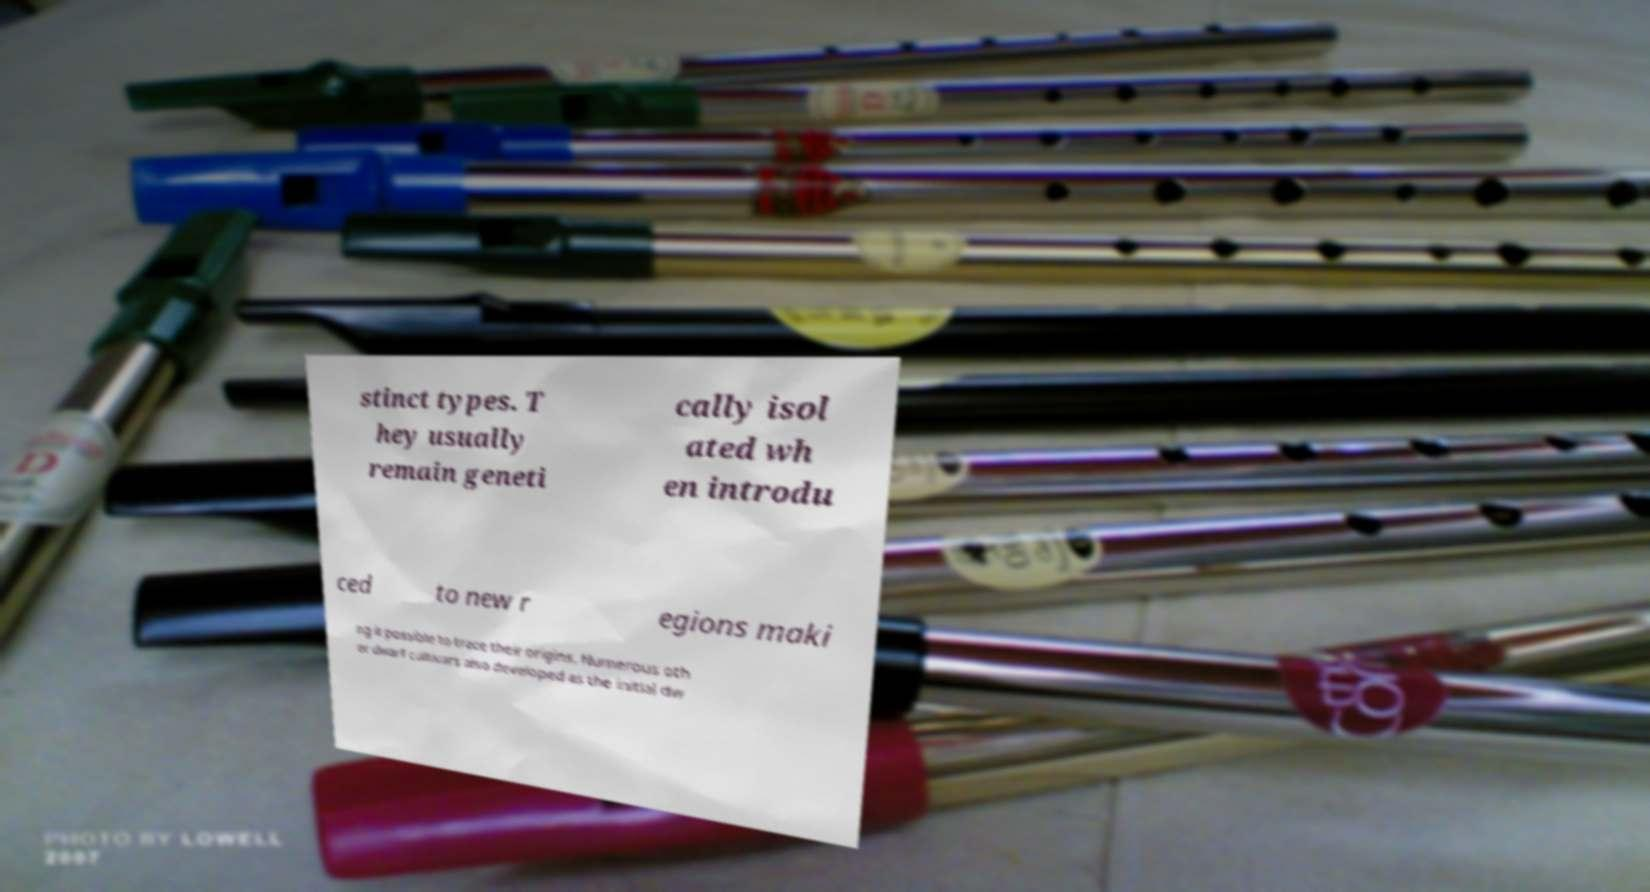Can you read and provide the text displayed in the image?This photo seems to have some interesting text. Can you extract and type it out for me? stinct types. T hey usually remain geneti cally isol ated wh en introdu ced to new r egions maki ng it possible to trace their origins. Numerous oth er dwarf cultivars also developed as the initial dw 